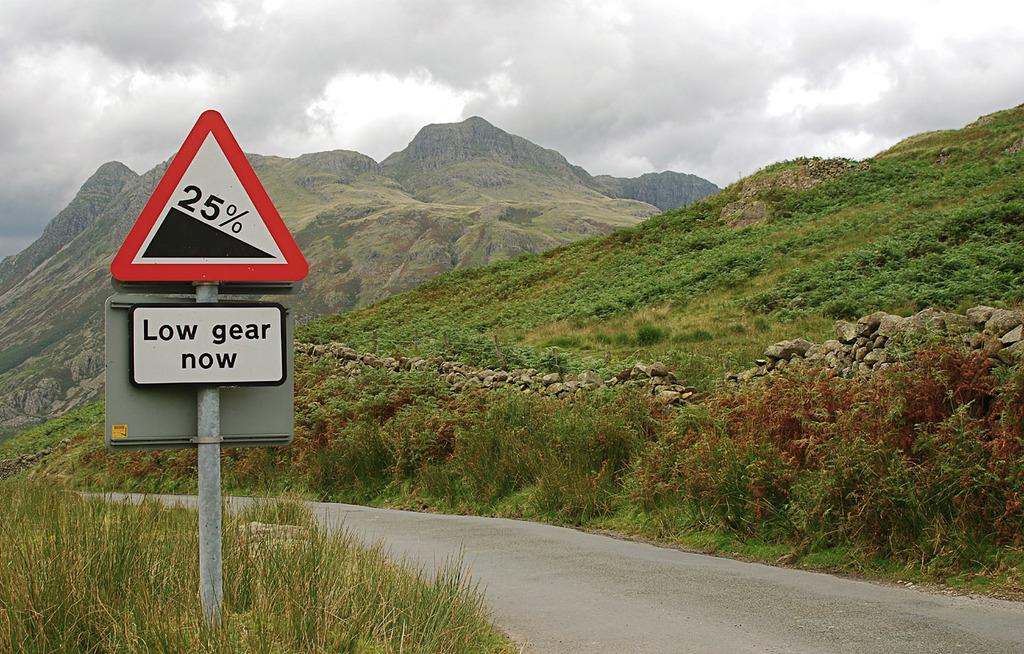<image>
Provide a brief description of the given image. A beautiful mountain top behind green grass, beside a sign reading Low gear now. 